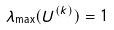Convert formula to latex. <formula><loc_0><loc_0><loc_500><loc_500>\lambda _ { \max } ( U ^ { ( k ) } ) = 1</formula> 